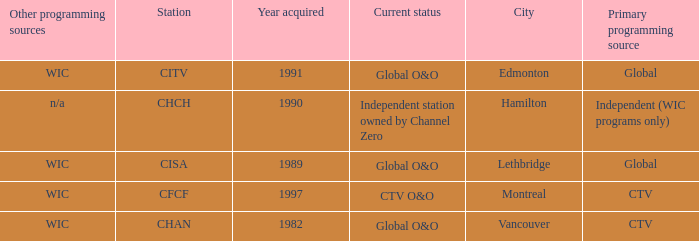Could you parse the entire table? {'header': ['Other programming sources', 'Station', 'Year acquired', 'Current status', 'City', 'Primary programming source'], 'rows': [['WIC', 'CITV', '1991', 'Global O&O', 'Edmonton', 'Global'], ['n/a', 'CHCH', '1990', 'Independent station owned by Channel Zero', 'Hamilton', 'Independent (WIC programs only)'], ['WIC', 'CISA', '1989', 'Global O&O', 'Lethbridge', 'Global'], ['WIC', 'CFCF', '1997', 'CTV O&O', 'Montreal', 'CTV'], ['WIC', 'CHAN', '1982', 'Global O&O', 'Vancouver', 'CTV']]} As the chan, how many were obtained? 1.0. 